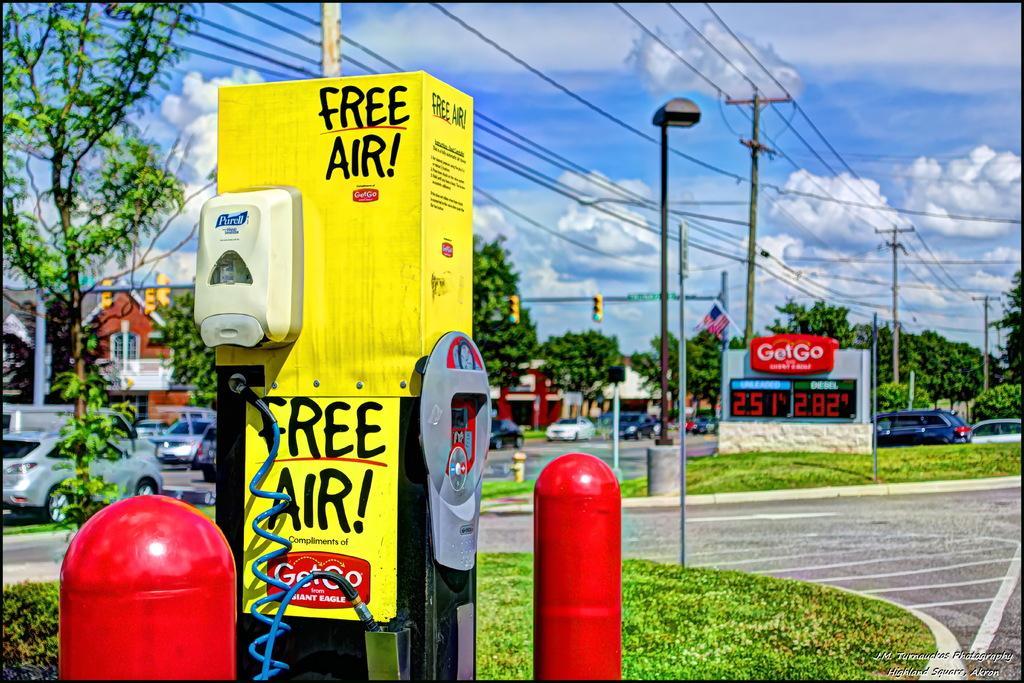How would you summarize this image in a sentence or two? This picture seems to be an edited image with the borders. In the foreground we can see a yellow color telephone booth and the red color objects and we can see the green grass. In the center we can see the poles, cables, trees, vehicles and some other objects. In the background we can see the sky with the clouds and we can see the houses and the traffic light and a light attached to the pole and we can see many other objects and we can see the text on the telephone booth and a banner and we can see a flag attached to the pole. 